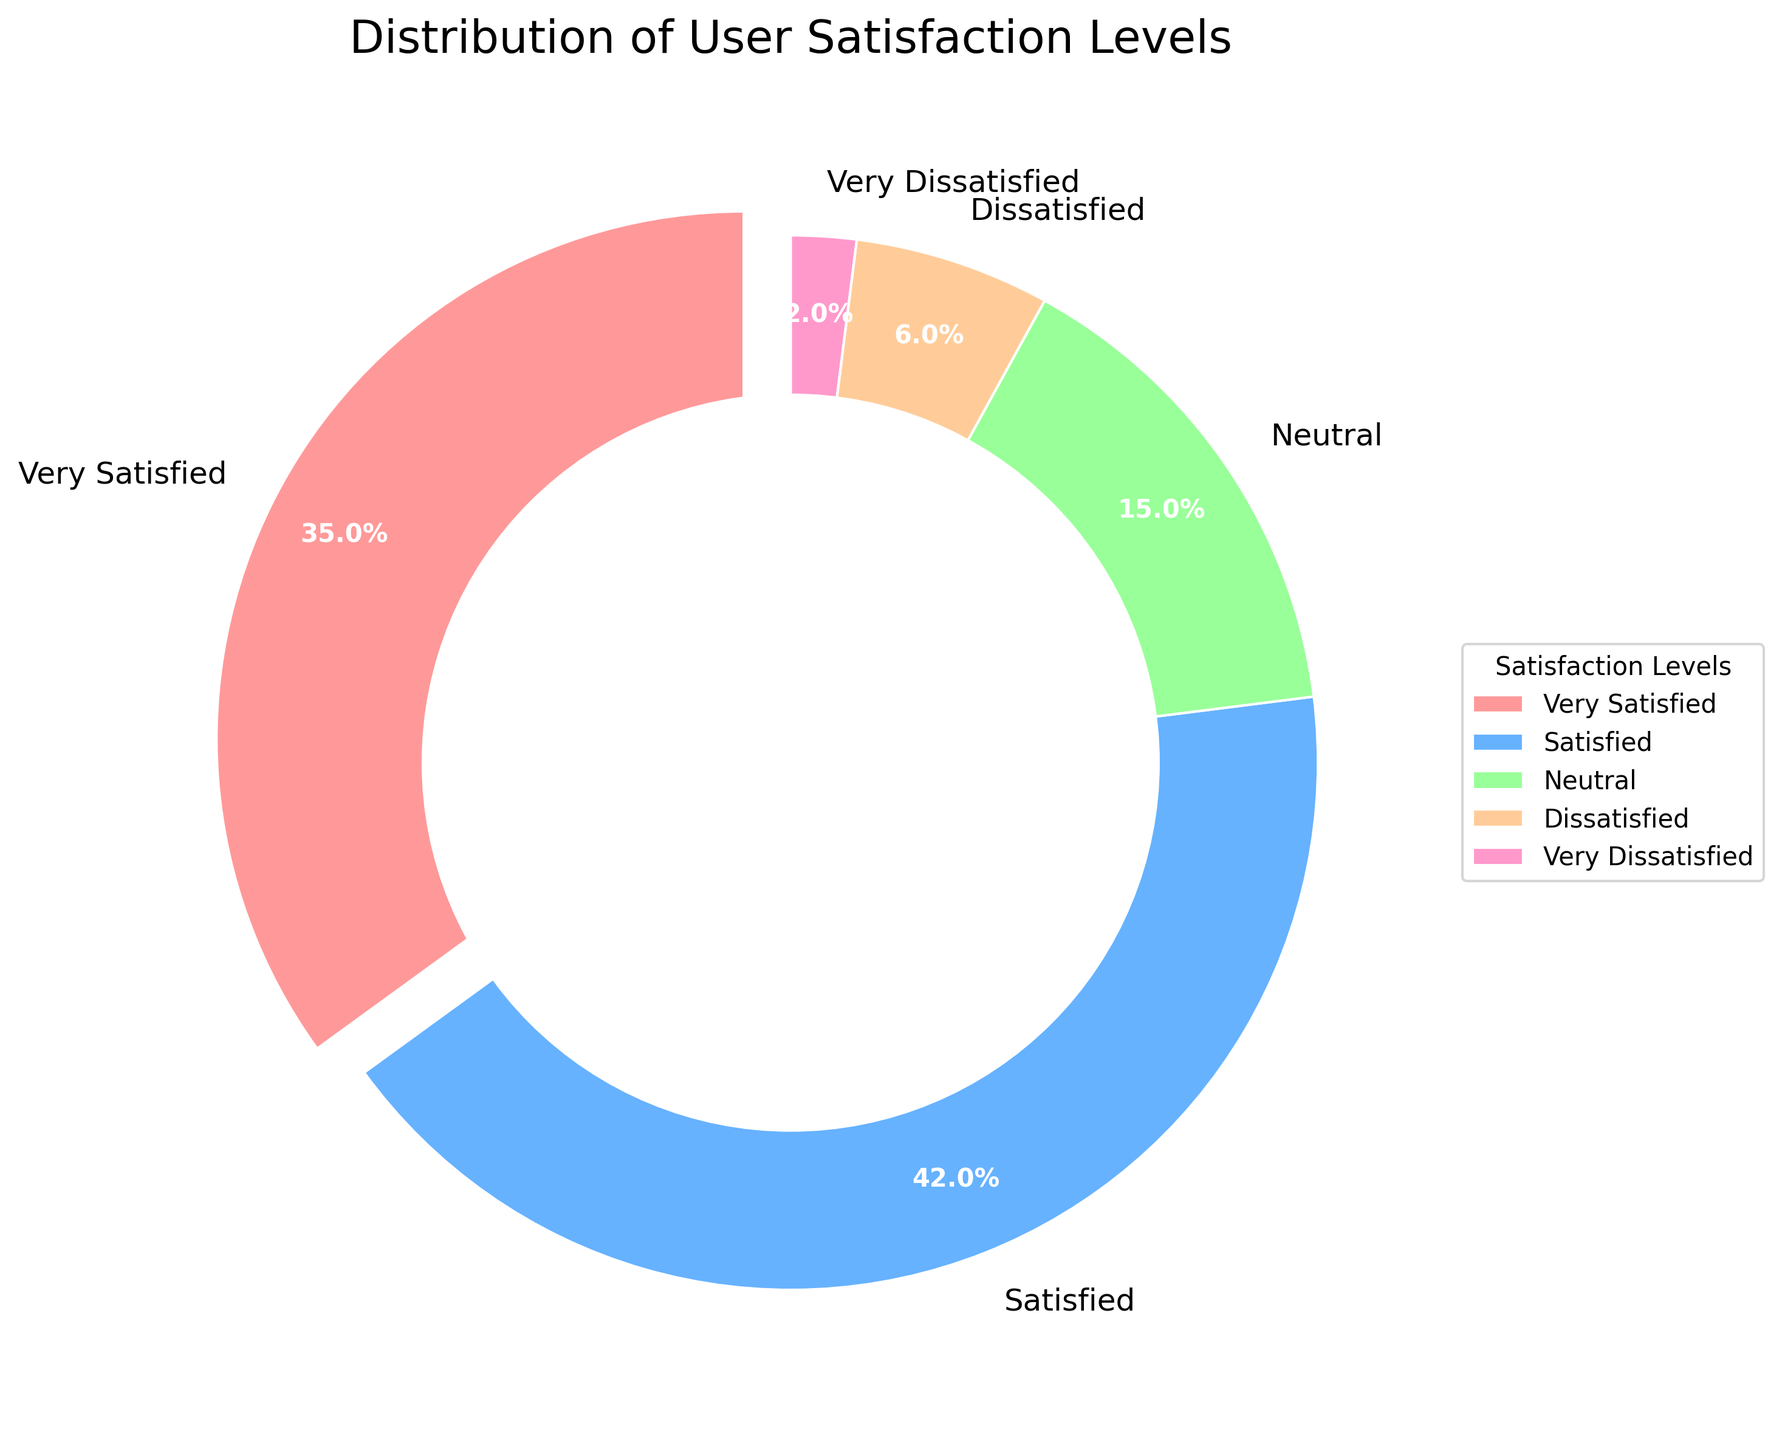What percentage of users are at least satisfied with the software? To determine the percentage of users at least satisfied, we need to sum the percentages of 'Very Satisfied' and 'Satisfied'. Adding 35% (Very Satisfied) and 42% (Satisfied), we get 35 + 42 = 77%.
Answer: 77% Which satisfaction level has the highest percentage of users? By examining the pie chart, 'Satisfied' has the highest percentage, which is 42%.
Answer: Satisfied What is the total percentage of users who are either dissatisfied or very dissatisfied? Add the percentages of 'Dissatisfied' and 'Very Dissatisfied'. That is 6% + 2% = 8%.
Answer: 8% How many more users are 'Satisfied' compared to 'Neutral'? 'Satisfied' users account for 42%, while 'Neutral' users account for 15%. To find the difference, subtract 15% from 42%, which is 42 - 15 = 27%.
Answer: 27% What is the difference in percentage between 'Very Satisfied' and 'Very Dissatisfied' users? 'Very Satisfied' users make up 35%, and 'Very Dissatisfied' users make up 2%. Subtracting these gives 35 - 2 = 33%.
Answer: 33% Which color represents the 'Dissatisfied' user satisfaction level? By referencing the colors in the chart's legend, 'Dissatisfied' is displayed in orange.
Answer: orange Are there more users that are 'Neutral' or 'Very Satisfied'? Compare the percentages of 'Neutral' (15%) and 'Very Satisfied' (35%). Since 35% is higher than 15%, there are more 'Very Satisfied' users.
Answer: Very Satisfied What fraction of users fall into the 'Very Dissatisfied' category? 'Very Dissatisfied' users are 2%. That is 2/100, which simplifies to 1/50.
Answer: 1/50 